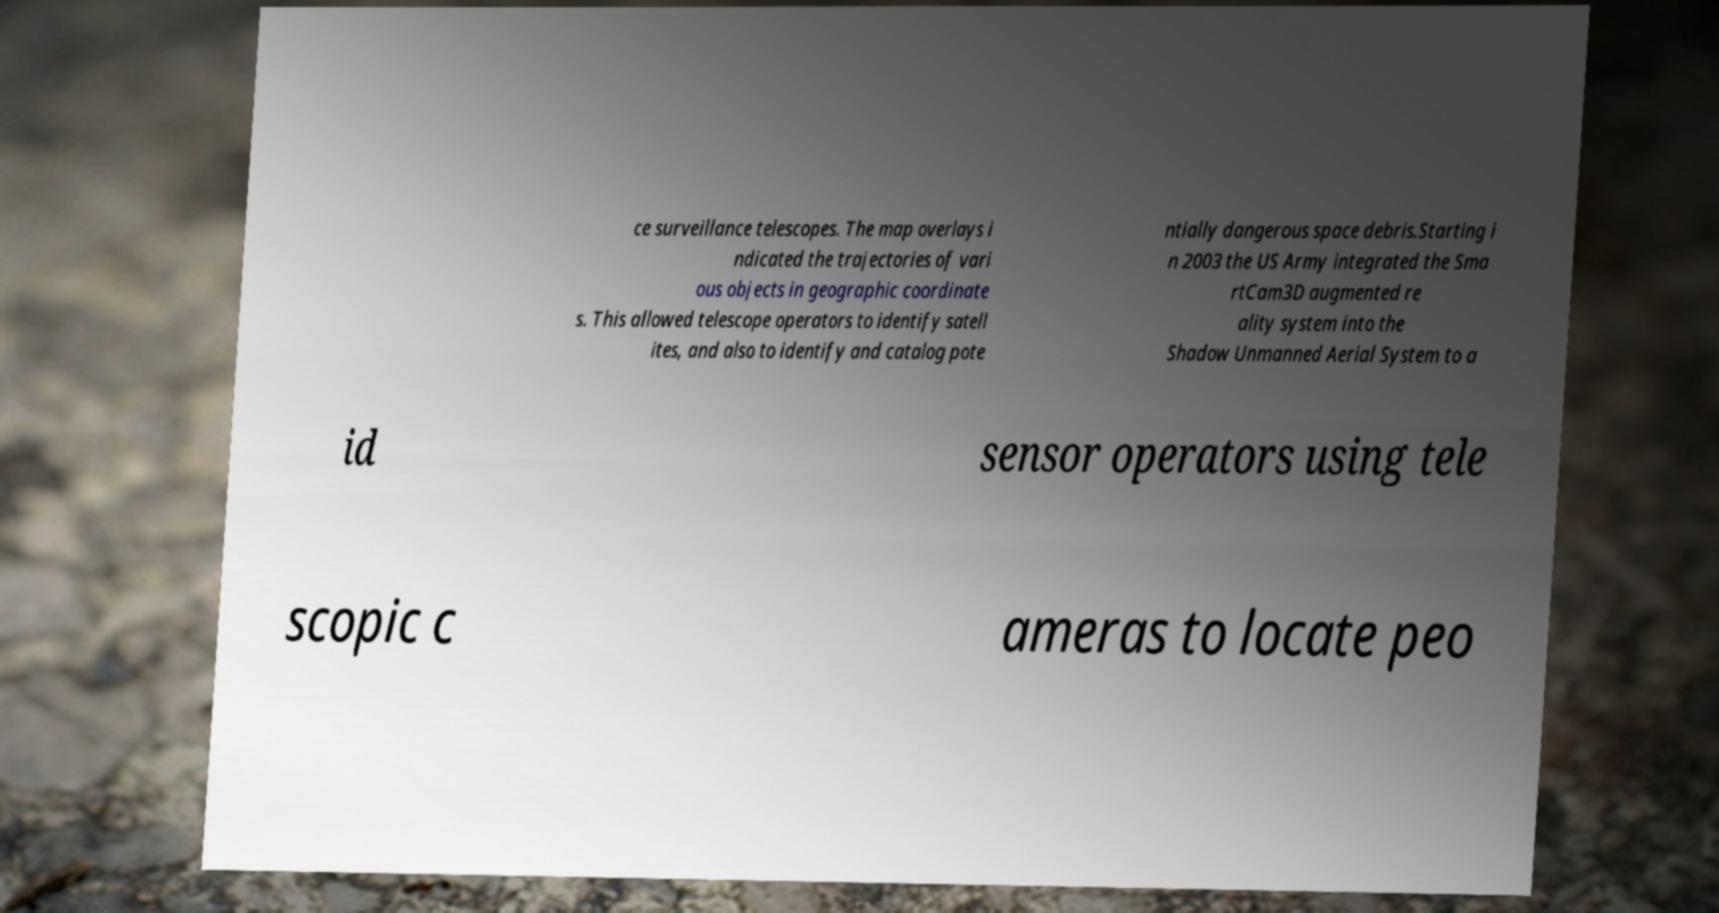Could you assist in decoding the text presented in this image and type it out clearly? ce surveillance telescopes. The map overlays i ndicated the trajectories of vari ous objects in geographic coordinate s. This allowed telescope operators to identify satell ites, and also to identify and catalog pote ntially dangerous space debris.Starting i n 2003 the US Army integrated the Sma rtCam3D augmented re ality system into the Shadow Unmanned Aerial System to a id sensor operators using tele scopic c ameras to locate peo 